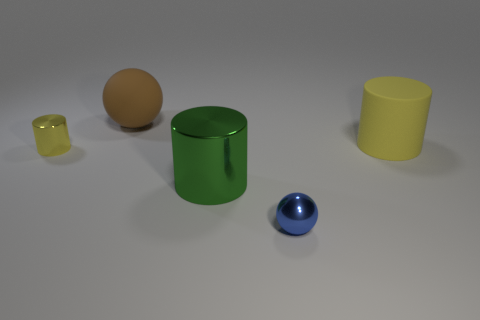Add 2 small yellow metallic things. How many objects exist? 7 Subtract all spheres. How many objects are left? 3 Add 3 tiny yellow cylinders. How many tiny yellow cylinders exist? 4 Subtract 0 red blocks. How many objects are left? 5 Subtract all big yellow rubber spheres. Subtract all tiny yellow metallic cylinders. How many objects are left? 4 Add 1 tiny yellow metal cylinders. How many tiny yellow metal cylinders are left? 2 